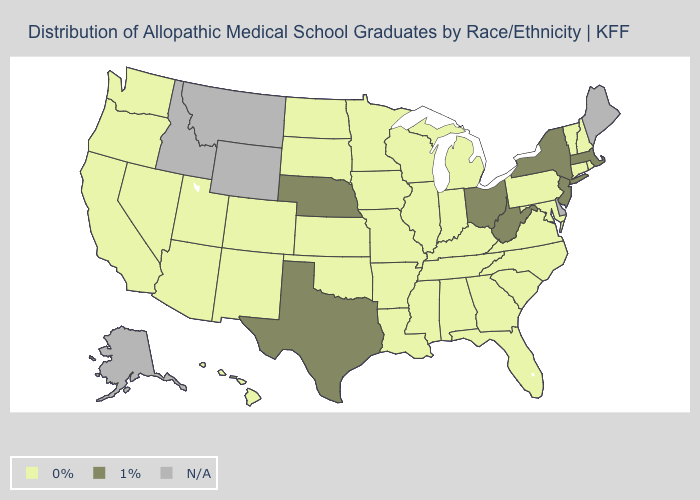Does South Carolina have the highest value in the South?
Give a very brief answer. No. Is the legend a continuous bar?
Give a very brief answer. No. Name the states that have a value in the range 0%?
Short answer required. Alabama, Arizona, Arkansas, California, Colorado, Connecticut, Florida, Georgia, Hawaii, Illinois, Indiana, Iowa, Kansas, Kentucky, Louisiana, Maryland, Michigan, Minnesota, Mississippi, Missouri, Nevada, New Hampshire, New Mexico, North Carolina, North Dakota, Oklahoma, Oregon, Pennsylvania, Rhode Island, South Carolina, South Dakota, Tennessee, Utah, Vermont, Virginia, Washington, Wisconsin. How many symbols are there in the legend?
Write a very short answer. 3. Does the first symbol in the legend represent the smallest category?
Give a very brief answer. Yes. Name the states that have a value in the range 0%?
Write a very short answer. Alabama, Arizona, Arkansas, California, Colorado, Connecticut, Florida, Georgia, Hawaii, Illinois, Indiana, Iowa, Kansas, Kentucky, Louisiana, Maryland, Michigan, Minnesota, Mississippi, Missouri, Nevada, New Hampshire, New Mexico, North Carolina, North Dakota, Oklahoma, Oregon, Pennsylvania, Rhode Island, South Carolina, South Dakota, Tennessee, Utah, Vermont, Virginia, Washington, Wisconsin. Does the first symbol in the legend represent the smallest category?
Answer briefly. Yes. Name the states that have a value in the range N/A?
Be succinct. Alaska, Delaware, Idaho, Maine, Montana, Wyoming. Among the states that border Colorado , which have the lowest value?
Quick response, please. Arizona, Kansas, New Mexico, Oklahoma, Utah. Name the states that have a value in the range 1%?
Concise answer only. Massachusetts, Nebraska, New Jersey, New York, Ohio, Texas, West Virginia. Among the states that border Virginia , does West Virginia have the lowest value?
Concise answer only. No. What is the value of South Carolina?
Quick response, please. 0%. What is the value of Vermont?
Answer briefly. 0%. 